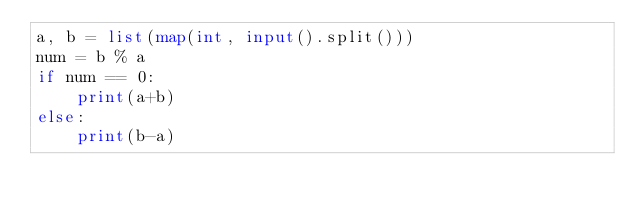<code> <loc_0><loc_0><loc_500><loc_500><_Python_>a, b = list(map(int, input().split()))
num = b % a
if num == 0:
    print(a+b)
else:
    print(b-a)</code> 